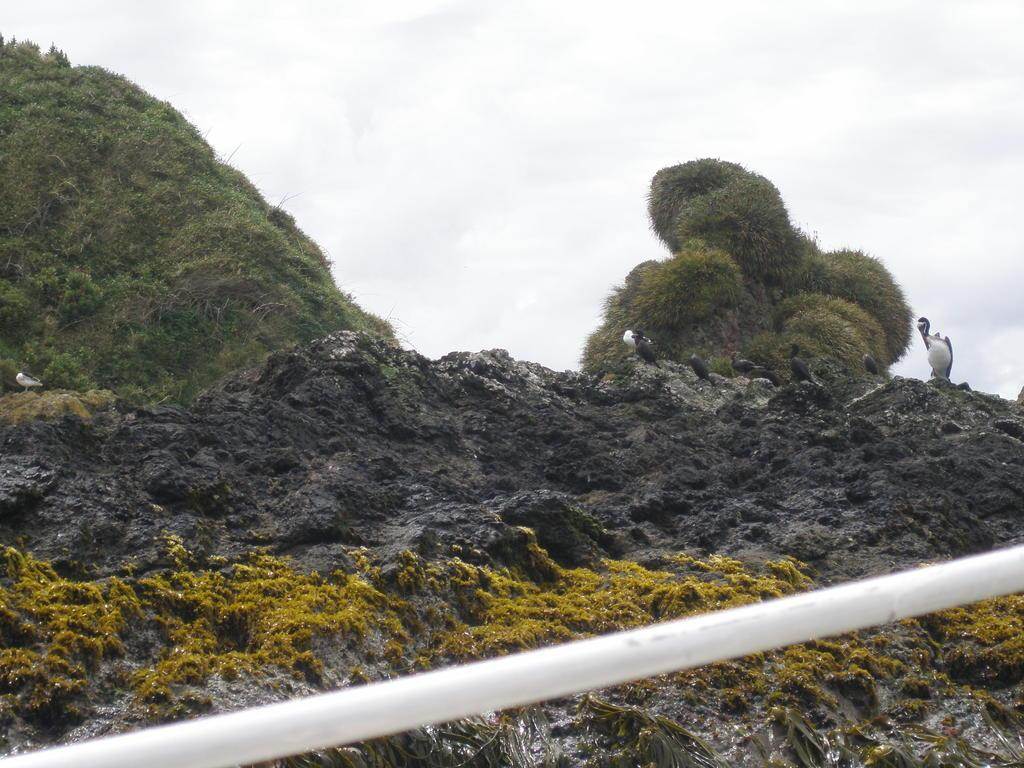What is located on the hill in the image? There are plants on a hill in the image. What can be seen on the right side of the image? There appears to be a bird on the right side of the image. How would you describe the sky in the image? The sky is cloudy in the image. Where is the desk located in the image? There is no desk present in the image. What type of rings can be seen on the bird's legs in the image? There are no rings visible on the bird's legs in the image, and there is no bird wearing rings. 